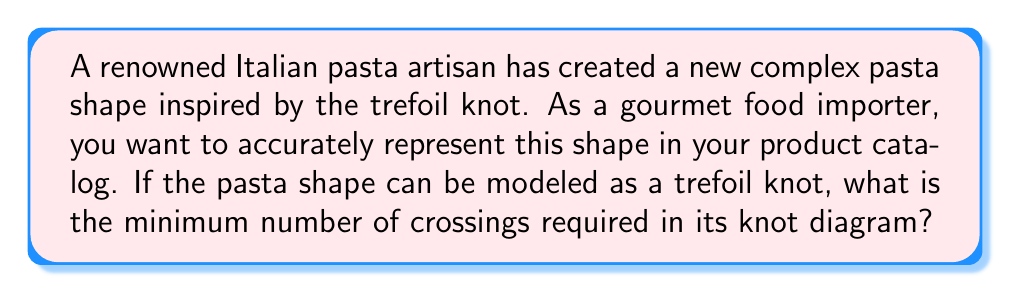Give your solution to this math problem. To determine the minimum number of crossings for the trefoil knot, we need to consider the following steps:

1. The trefoil knot is one of the simplest non-trivial knots in knot theory.

2. It is classified as a $(2,3)$-torus knot, meaning it can be drawn on the surface of a torus making 2 revolutions around the longitudinal direction and 3 revolutions around the meridional direction.

3. For any $(p,q)$-torus knot, where $p$ and $q$ are coprime integers, the minimum crossing number is given by the formula:

   $$ c_{min} = \min(p(q-1), q(p-1)) $$

4. In our case, $p=2$ and $q=3$. Let's calculate both possibilities:
   
   $p(q-1) = 2(3-1) = 2(2) = 4$
   $q(p-1) = 3(2-1) = 3(1) = 3$

5. The minimum of these two values is 3.

Therefore, the minimum number of crossings required to represent the trefoil knot (and consequently, the complex pasta shape inspired by it) is 3.
Answer: 3 crossings 